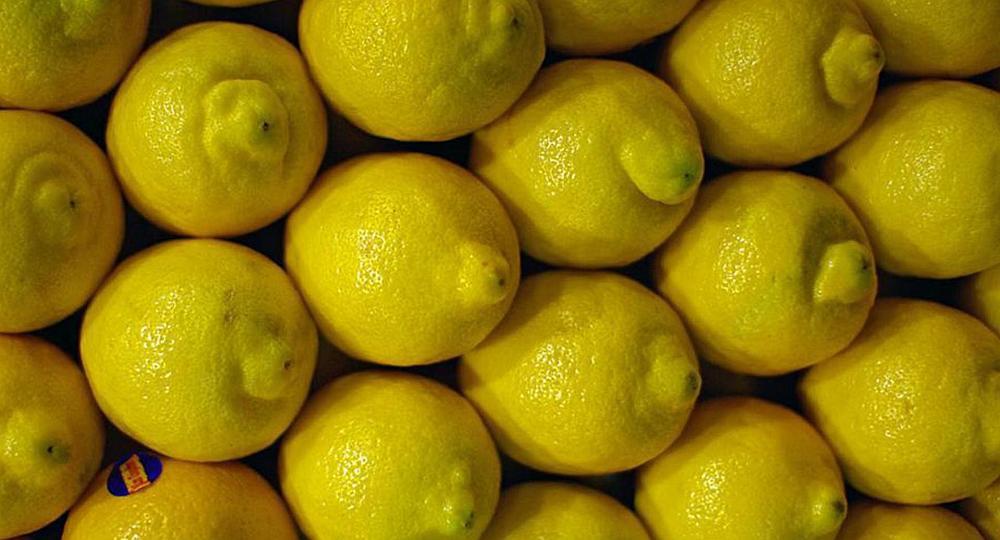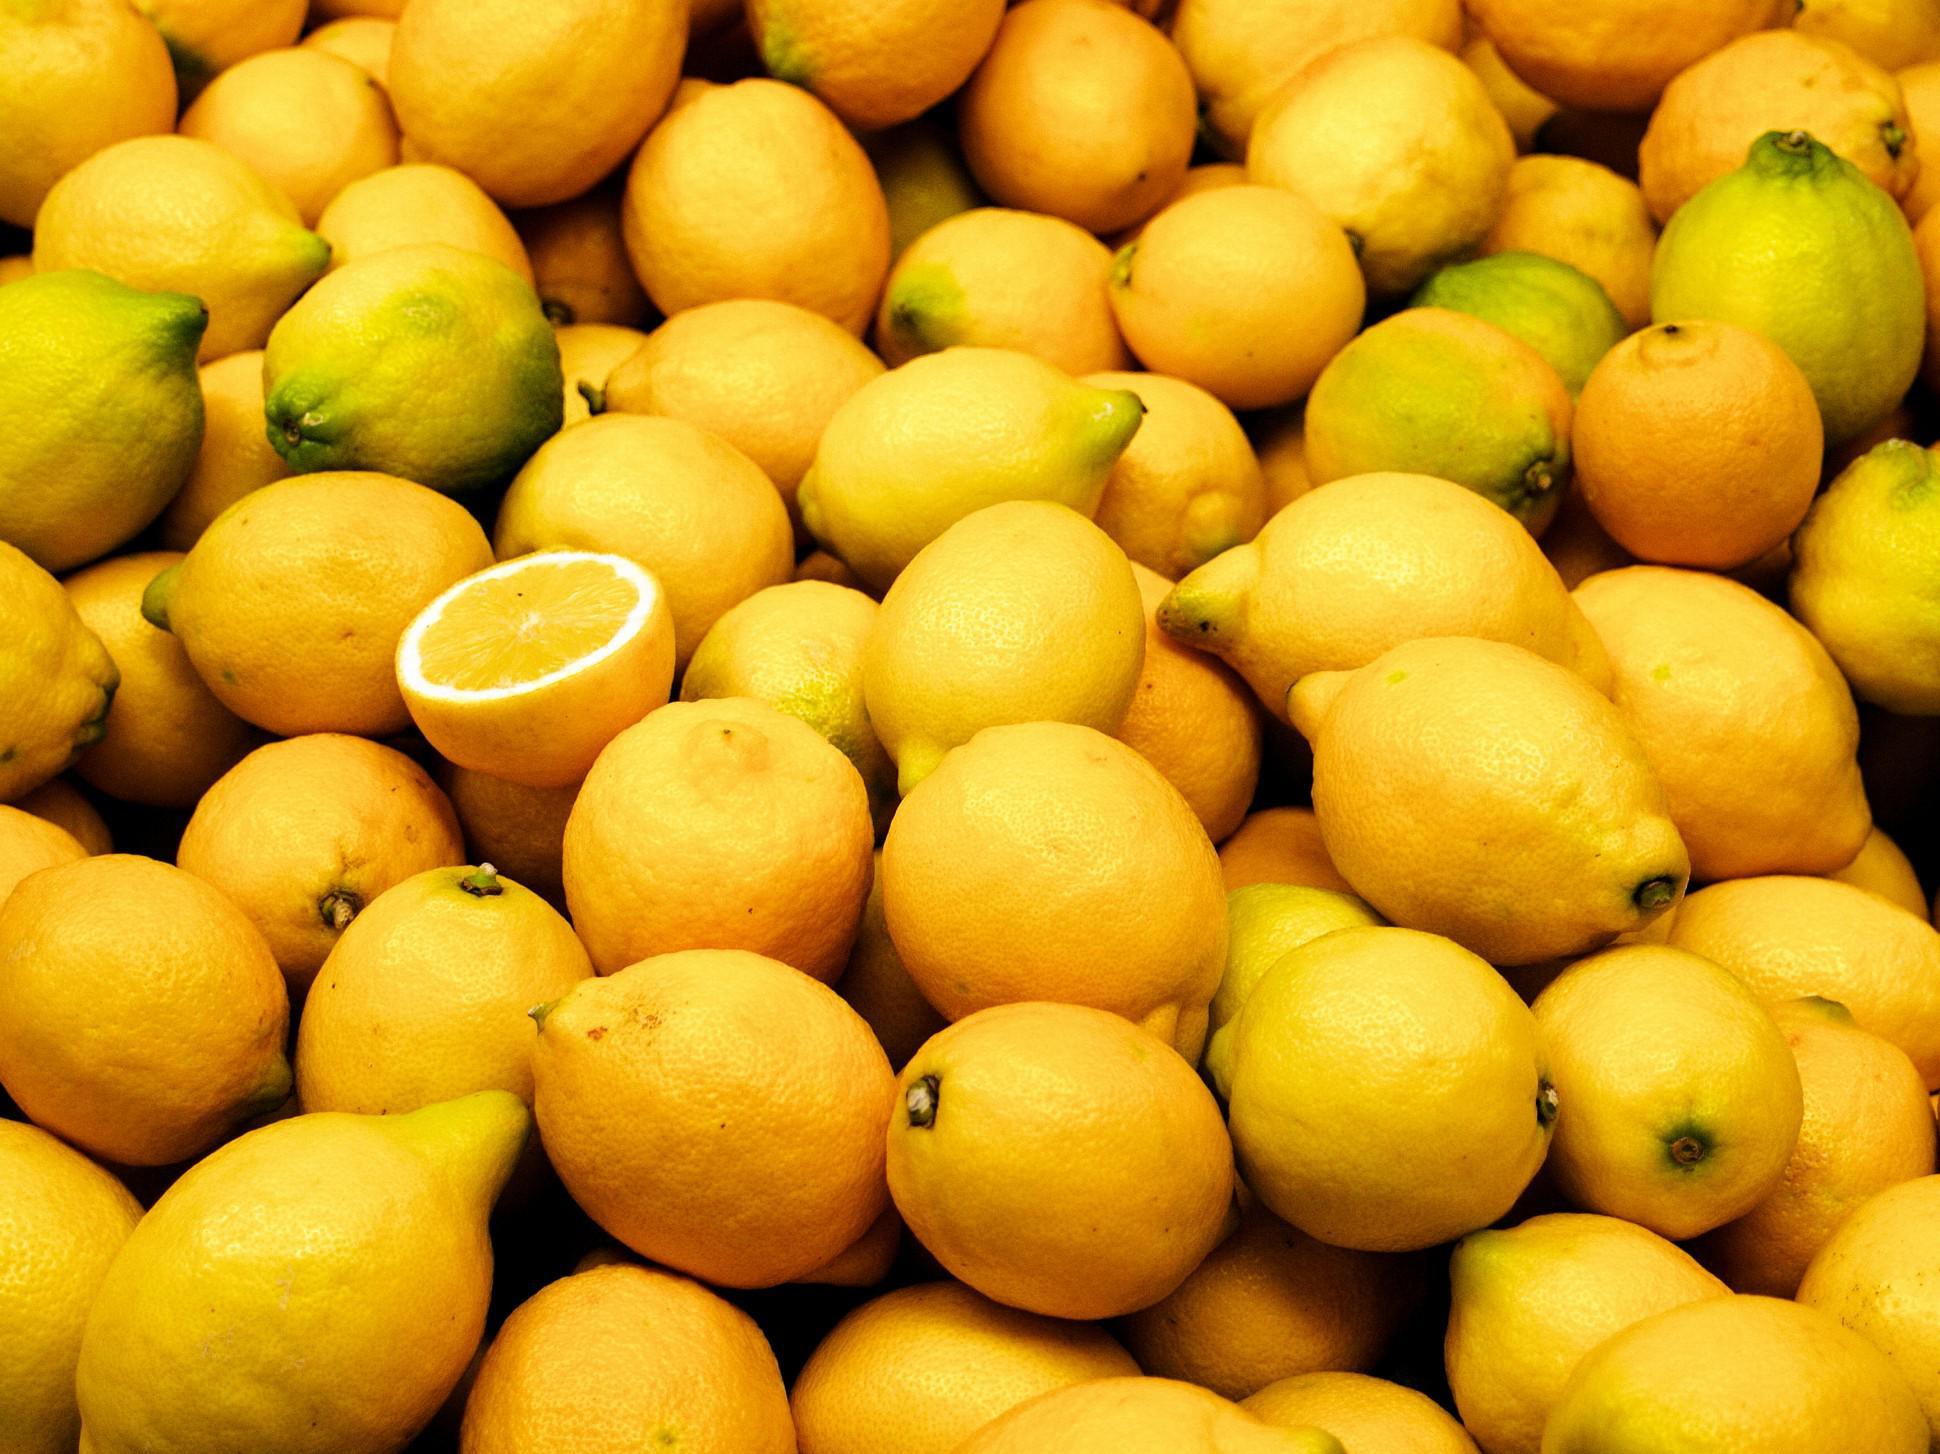The first image is the image on the left, the second image is the image on the right. For the images displayed, is the sentence "In at least one image there is a box of lemons with at least six that have blue stickers." factually correct? Answer yes or no. No. The first image is the image on the left, the second image is the image on the right. For the images shown, is this caption "Some of the lemons are packaged." true? Answer yes or no. No. 